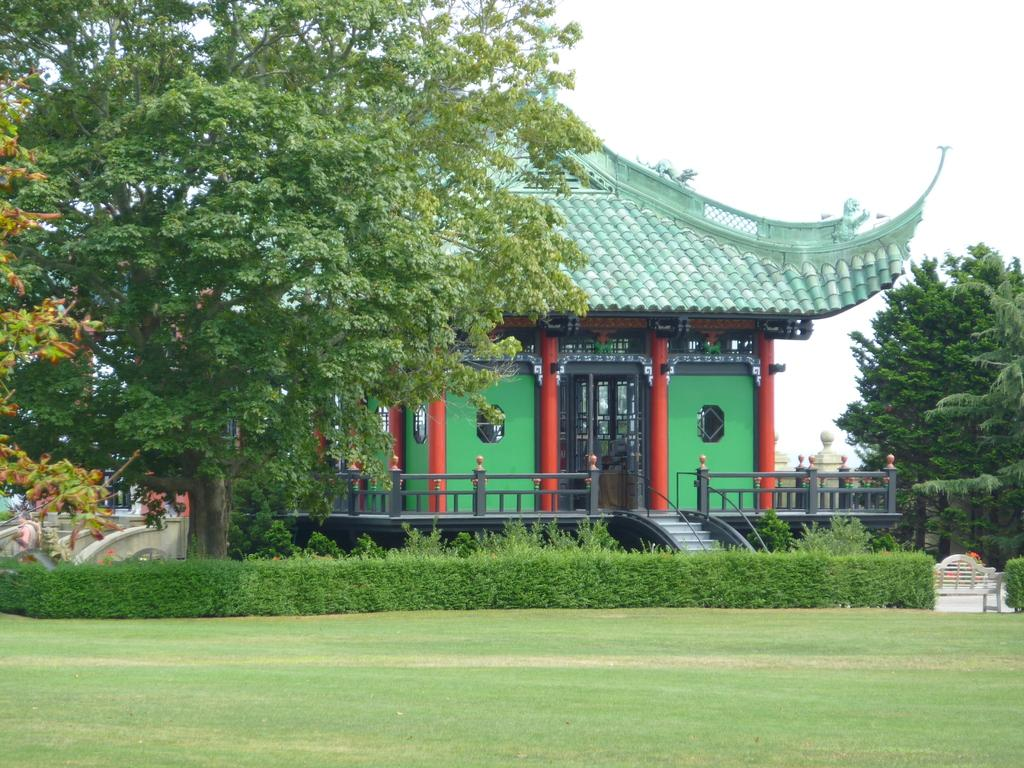What type of ground surface is visible in the image? There is grass on the ground in the image. What can be seen in the center of the image? There are plants in the center of the image. What is visible in the background of the image? There are trees and a house in the background of the image. How would you describe the sky in the image? The sky is cloudy in the image. What type of pancake is being served on the alarm in the image? There is no pancake or alarm present in the image. How does the sand in the image contribute to the overall scene? There is no sand present in the image. 